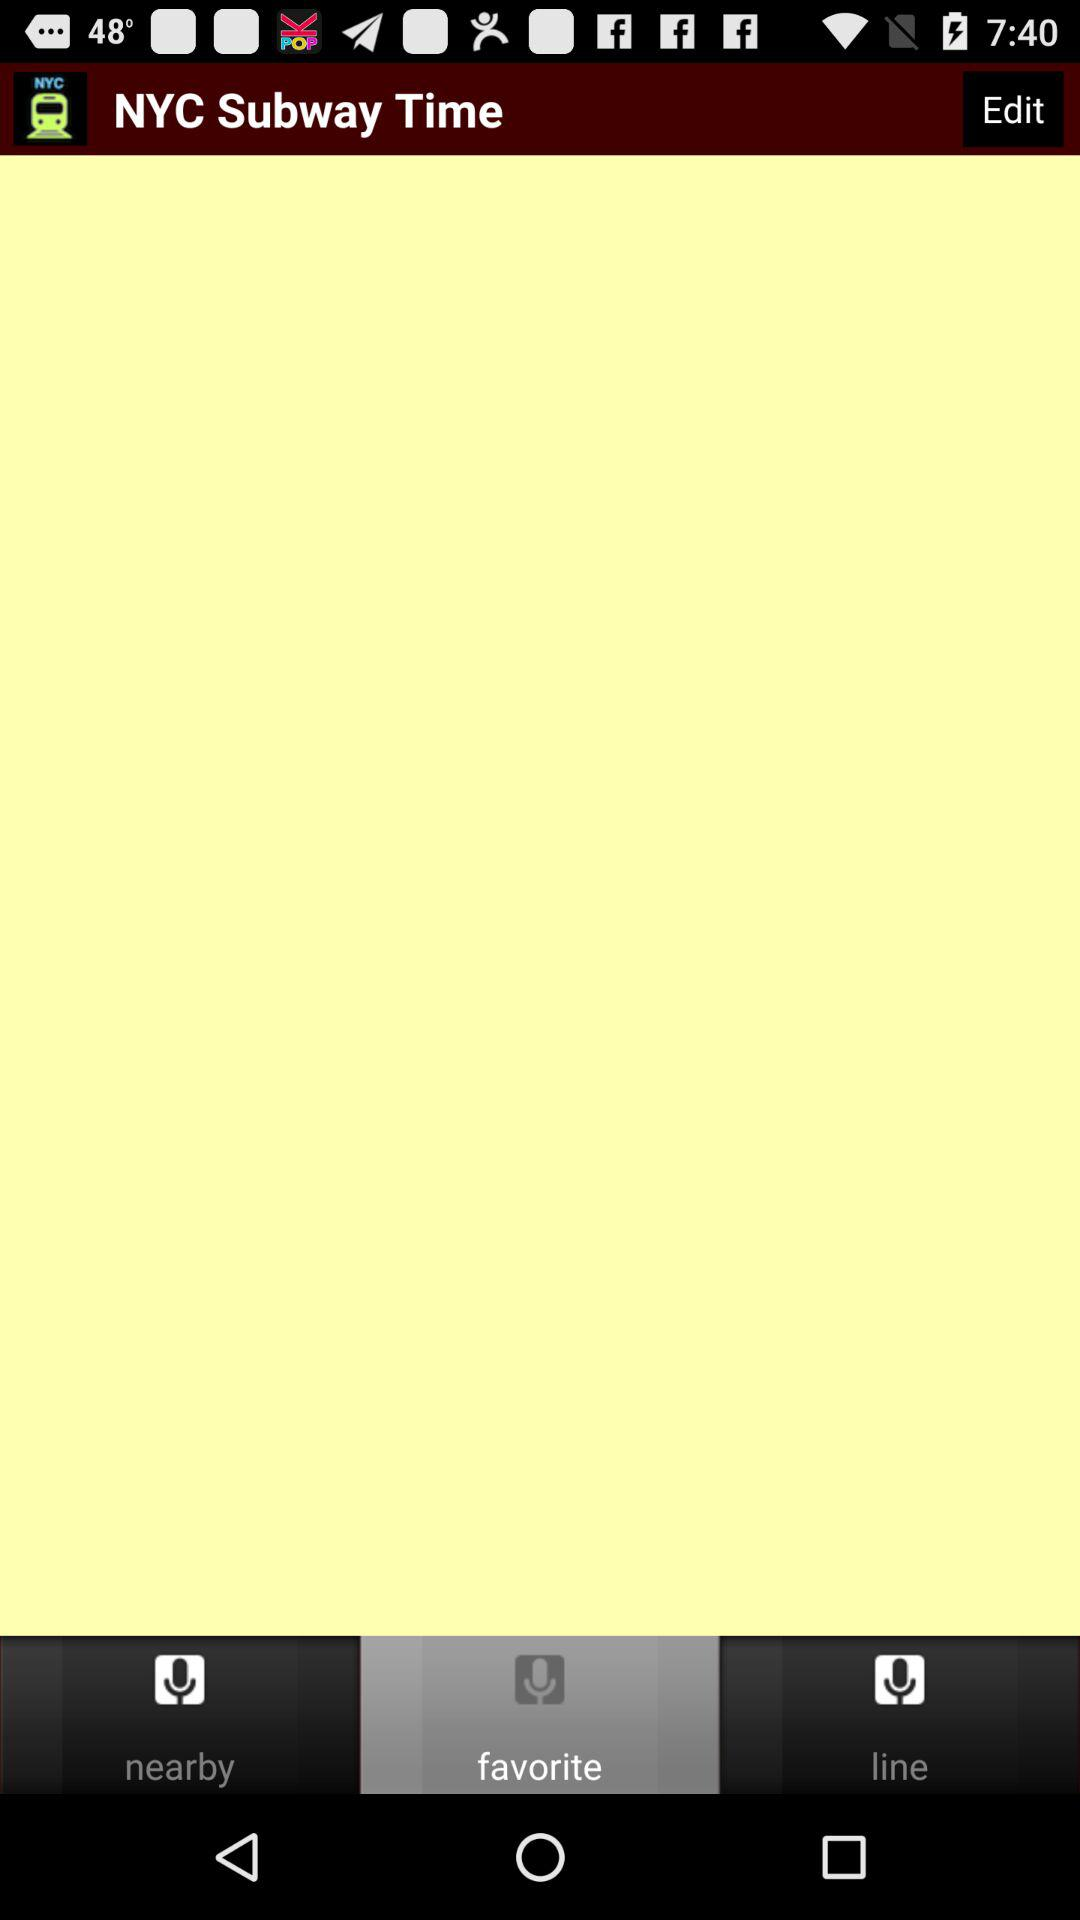How many subway stations are nearby?
When the provided information is insufficient, respond with <no answer>. <no answer> 